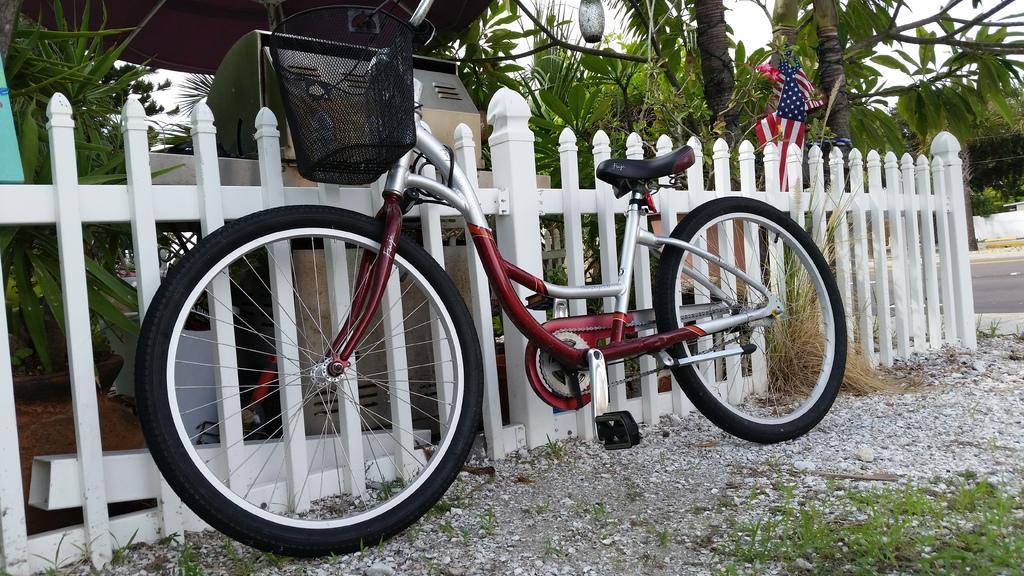How would you summarize this image in a sentence or two? In this image in the center there is one cycle and in the background there is fence and some box, trees, flag, light and some objects. At the bottom there are stones, grass, sand and on the right side of the image there is a walkway. 